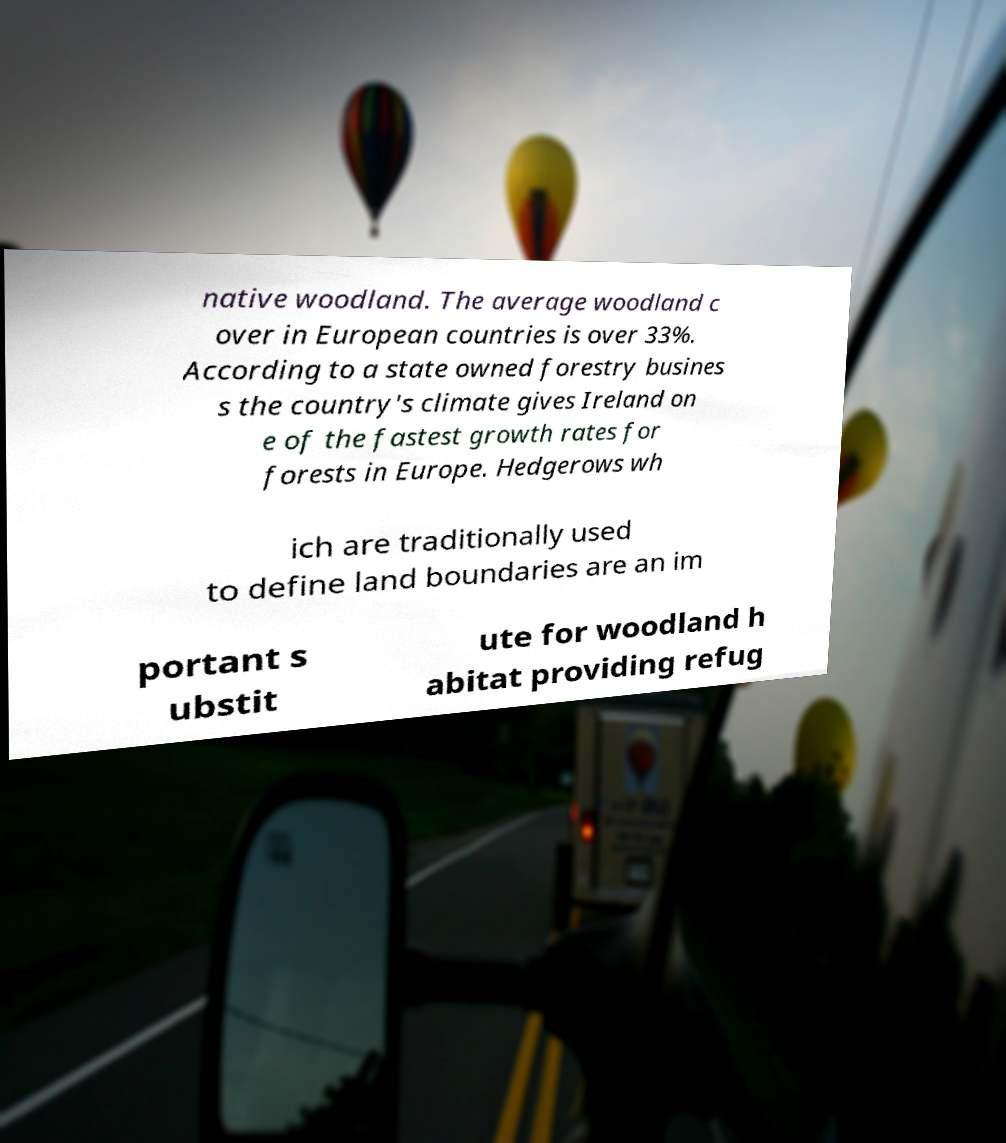There's text embedded in this image that I need extracted. Can you transcribe it verbatim? native woodland. The average woodland c over in European countries is over 33%. According to a state owned forestry busines s the country's climate gives Ireland on e of the fastest growth rates for forests in Europe. Hedgerows wh ich are traditionally used to define land boundaries are an im portant s ubstit ute for woodland h abitat providing refug 